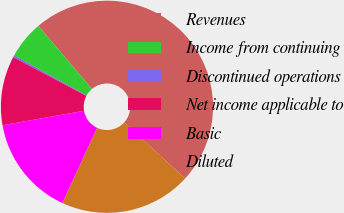Convert chart. <chart><loc_0><loc_0><loc_500><loc_500><pie_chart><fcel>Revenues<fcel>Income from continuing<fcel>Discontinued operations<fcel>Net income applicable to<fcel>Basic<fcel>Diluted<nl><fcel>48.01%<fcel>5.77%<fcel>0.29%<fcel>10.54%<fcel>15.31%<fcel>20.08%<nl></chart> 